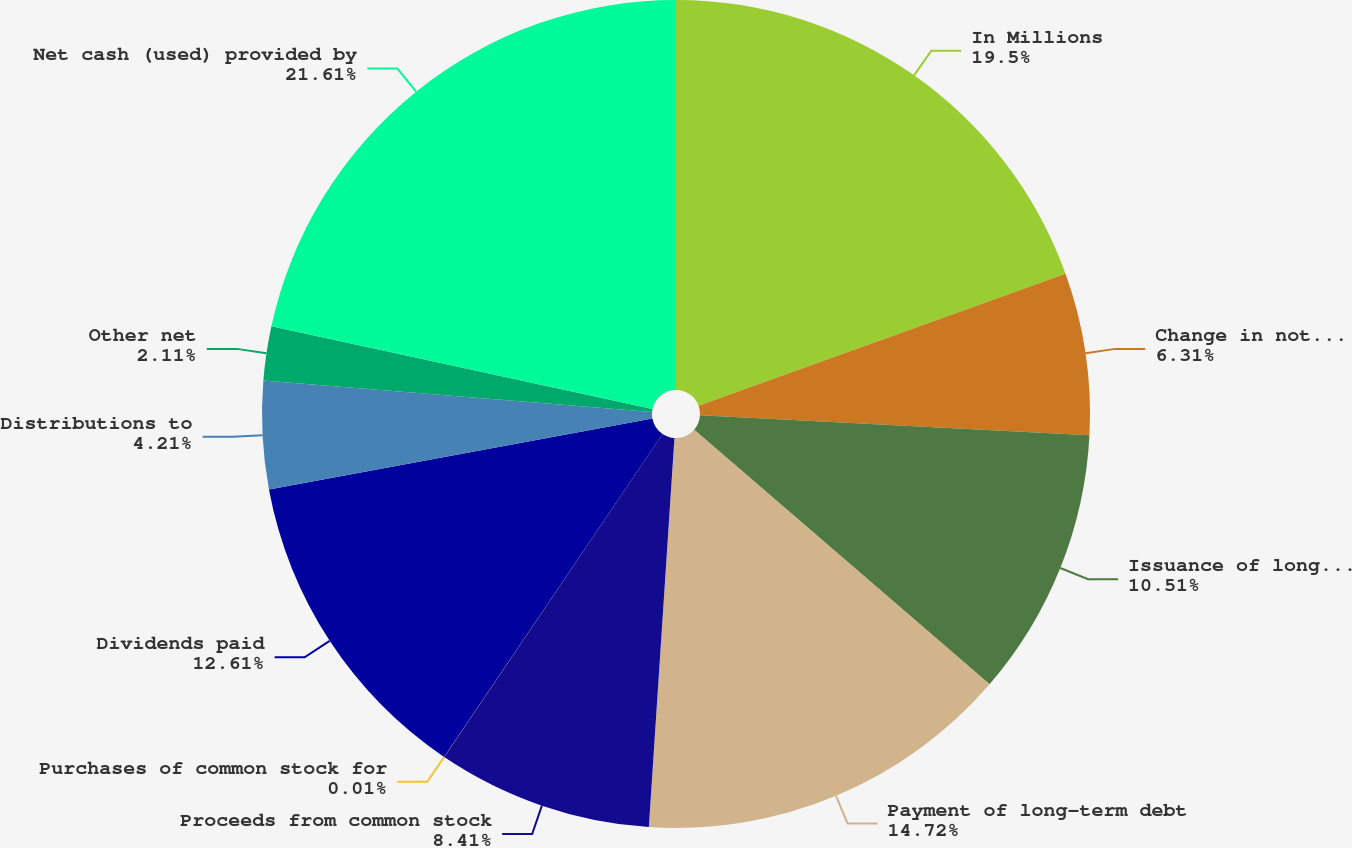<chart> <loc_0><loc_0><loc_500><loc_500><pie_chart><fcel>In Millions<fcel>Change in notes payable<fcel>Issuance of long-term debt<fcel>Payment of long-term debt<fcel>Proceeds from common stock<fcel>Purchases of common stock for<fcel>Dividends paid<fcel>Distributions to<fcel>Other net<fcel>Net cash (used) provided by<nl><fcel>19.5%<fcel>6.31%<fcel>10.51%<fcel>14.72%<fcel>8.41%<fcel>0.01%<fcel>12.61%<fcel>4.21%<fcel>2.11%<fcel>21.6%<nl></chart> 